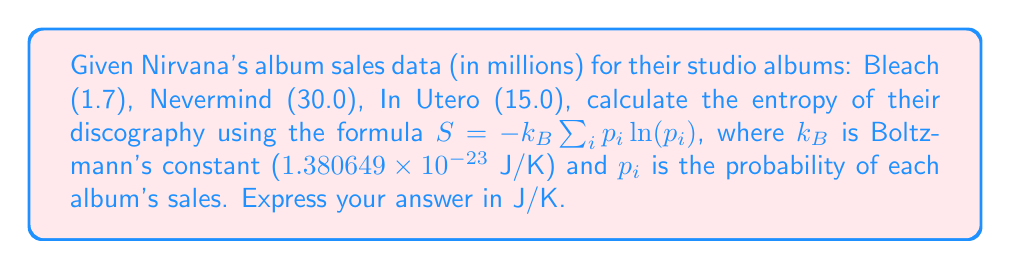Give your solution to this math problem. 1. Calculate the total album sales:
   Total sales = 1.7 + 30.0 + 15.0 = 46.7 million

2. Calculate the probability ($p_i$) for each album:
   $p_{Bleach} = 1.7 / 46.7 = 0.0364$
   $p_{Nevermind} = 30.0 / 46.7 = 0.6424$
   $p_{InUtero} = 15.0 / 46.7 = 0.3212$

3. Apply the entropy formula:
   $S = -k_B \sum_{i} p_i \ln(p_i)$
   $S = -k_B [0.0364 \ln(0.0364) + 0.6424 \ln(0.6424) + 0.3212 \ln(0.3212)]$

4. Calculate the sum inside the brackets:
   $0.0364 \ln(0.0364) = -0.1202$
   $0.6424 \ln(0.6424) = -0.2844$
   $0.3212 \ln(0.3212) = -0.3645$
   Sum = -0.1202 - 0.2844 - 0.3645 = -0.7691

5. Multiply by Boltzmann's constant:
   $S = -(1.380649 \times 10^{-23}) \times (-0.7691)$
   $S = 1.061697 \times 10^{-23}$ J/K
Answer: $1.062 \times 10^{-23}$ J/K 